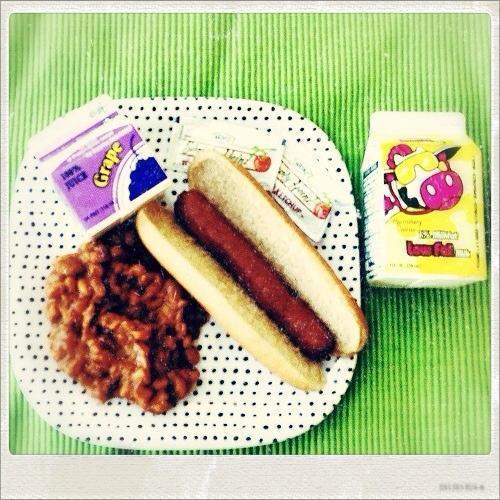How many drinks are there?
Give a very brief answer. 2. How many hot dogs are there?
Give a very brief answer. 1. 